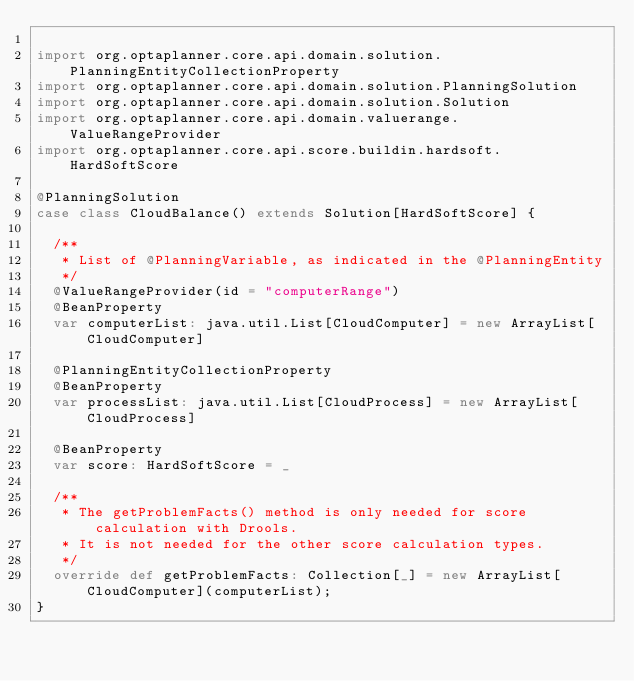Convert code to text. <code><loc_0><loc_0><loc_500><loc_500><_Scala_>
import org.optaplanner.core.api.domain.solution.PlanningEntityCollectionProperty
import org.optaplanner.core.api.domain.solution.PlanningSolution
import org.optaplanner.core.api.domain.solution.Solution
import org.optaplanner.core.api.domain.valuerange.ValueRangeProvider
import org.optaplanner.core.api.score.buildin.hardsoft.HardSoftScore

@PlanningSolution
case class CloudBalance() extends Solution[HardSoftScore] {

  /**
   * List of @PlanningVariable, as indicated in the @PlanningEntity
   */
  @ValueRangeProvider(id = "computerRange")
  @BeanProperty
  var computerList: java.util.List[CloudComputer] = new ArrayList[CloudComputer]

  @PlanningEntityCollectionProperty
  @BeanProperty
  var processList: java.util.List[CloudProcess] = new ArrayList[CloudProcess]

  @BeanProperty
  var score: HardSoftScore = _

  /**
   * The getProblemFacts() method is only needed for score calculation with Drools.
   * It is not needed for the other score calculation types.
   */
  override def getProblemFacts: Collection[_] = new ArrayList[CloudComputer](computerList);
}</code> 